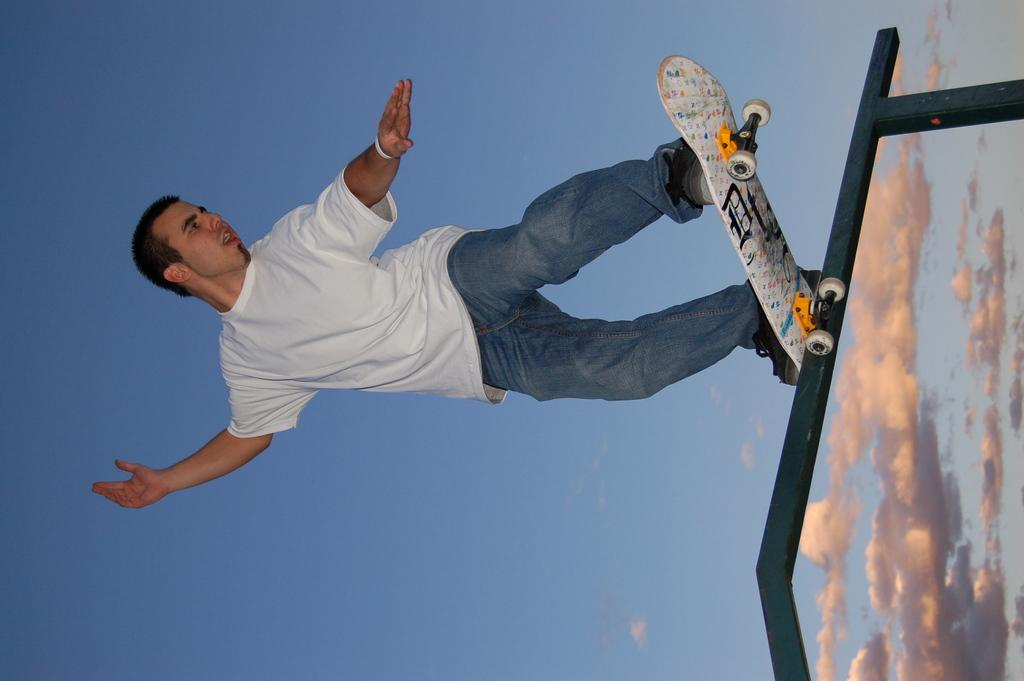What is the main subject of the image? There is a person in the image. What is the person doing in the image? The person is on a skateboard. How is the skateboard positioned in the image? The skateboard is on a stand. What is the weather like in the image? The sky is blue and cloudy. What type of appliance can be seen on the person's head in the image? There is no appliance visible on the person's head in the image. How many scissors are being used by the person in the image? There are no scissors present in the image. 